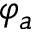Convert formula to latex. <formula><loc_0><loc_0><loc_500><loc_500>\varphi _ { a }</formula> 